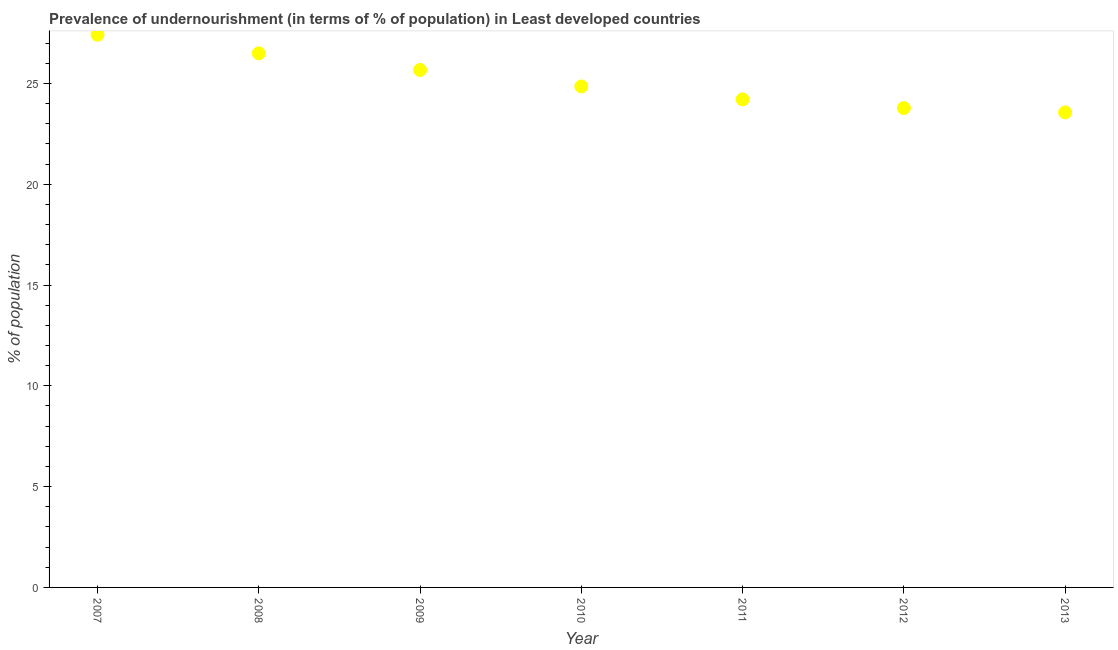What is the percentage of undernourished population in 2012?
Provide a short and direct response. 23.78. Across all years, what is the maximum percentage of undernourished population?
Offer a very short reply. 27.42. Across all years, what is the minimum percentage of undernourished population?
Ensure brevity in your answer.  23.57. What is the sum of the percentage of undernourished population?
Provide a succinct answer. 175.99. What is the difference between the percentage of undernourished population in 2007 and 2010?
Your answer should be very brief. 2.57. What is the average percentage of undernourished population per year?
Your answer should be very brief. 25.14. What is the median percentage of undernourished population?
Make the answer very short. 24.85. In how many years, is the percentage of undernourished population greater than 14 %?
Your answer should be very brief. 7. What is the ratio of the percentage of undernourished population in 2007 to that in 2011?
Offer a very short reply. 1.13. What is the difference between the highest and the second highest percentage of undernourished population?
Offer a very short reply. 0.92. What is the difference between the highest and the lowest percentage of undernourished population?
Offer a terse response. 3.85. In how many years, is the percentage of undernourished population greater than the average percentage of undernourished population taken over all years?
Offer a very short reply. 3. What is the difference between two consecutive major ticks on the Y-axis?
Your response must be concise. 5. What is the title of the graph?
Offer a terse response. Prevalence of undernourishment (in terms of % of population) in Least developed countries. What is the label or title of the Y-axis?
Provide a succinct answer. % of population. What is the % of population in 2007?
Give a very brief answer. 27.42. What is the % of population in 2008?
Keep it short and to the point. 26.49. What is the % of population in 2009?
Your response must be concise. 25.67. What is the % of population in 2010?
Offer a very short reply. 24.85. What is the % of population in 2011?
Provide a short and direct response. 24.21. What is the % of population in 2012?
Give a very brief answer. 23.78. What is the % of population in 2013?
Your response must be concise. 23.57. What is the difference between the % of population in 2007 and 2008?
Provide a short and direct response. 0.92. What is the difference between the % of population in 2007 and 2009?
Your answer should be very brief. 1.75. What is the difference between the % of population in 2007 and 2010?
Make the answer very short. 2.57. What is the difference between the % of population in 2007 and 2011?
Your answer should be compact. 3.21. What is the difference between the % of population in 2007 and 2012?
Keep it short and to the point. 3.64. What is the difference between the % of population in 2007 and 2013?
Offer a very short reply. 3.85. What is the difference between the % of population in 2008 and 2009?
Your response must be concise. 0.82. What is the difference between the % of population in 2008 and 2010?
Ensure brevity in your answer.  1.64. What is the difference between the % of population in 2008 and 2011?
Provide a succinct answer. 2.28. What is the difference between the % of population in 2008 and 2012?
Give a very brief answer. 2.71. What is the difference between the % of population in 2008 and 2013?
Provide a short and direct response. 2.93. What is the difference between the % of population in 2009 and 2010?
Offer a very short reply. 0.82. What is the difference between the % of population in 2009 and 2011?
Offer a terse response. 1.46. What is the difference between the % of population in 2009 and 2012?
Provide a short and direct response. 1.89. What is the difference between the % of population in 2009 and 2013?
Keep it short and to the point. 2.1. What is the difference between the % of population in 2010 and 2011?
Provide a short and direct response. 0.64. What is the difference between the % of population in 2010 and 2012?
Make the answer very short. 1.07. What is the difference between the % of population in 2010 and 2013?
Provide a short and direct response. 1.29. What is the difference between the % of population in 2011 and 2012?
Ensure brevity in your answer.  0.43. What is the difference between the % of population in 2011 and 2013?
Your answer should be compact. 0.65. What is the difference between the % of population in 2012 and 2013?
Provide a short and direct response. 0.21. What is the ratio of the % of population in 2007 to that in 2008?
Offer a terse response. 1.03. What is the ratio of the % of population in 2007 to that in 2009?
Your response must be concise. 1.07. What is the ratio of the % of population in 2007 to that in 2010?
Offer a very short reply. 1.1. What is the ratio of the % of population in 2007 to that in 2011?
Provide a succinct answer. 1.13. What is the ratio of the % of population in 2007 to that in 2012?
Make the answer very short. 1.15. What is the ratio of the % of population in 2007 to that in 2013?
Your answer should be compact. 1.16. What is the ratio of the % of population in 2008 to that in 2009?
Give a very brief answer. 1.03. What is the ratio of the % of population in 2008 to that in 2010?
Make the answer very short. 1.07. What is the ratio of the % of population in 2008 to that in 2011?
Keep it short and to the point. 1.09. What is the ratio of the % of population in 2008 to that in 2012?
Provide a short and direct response. 1.11. What is the ratio of the % of population in 2008 to that in 2013?
Make the answer very short. 1.12. What is the ratio of the % of population in 2009 to that in 2010?
Give a very brief answer. 1.03. What is the ratio of the % of population in 2009 to that in 2011?
Offer a terse response. 1.06. What is the ratio of the % of population in 2009 to that in 2012?
Your answer should be very brief. 1.08. What is the ratio of the % of population in 2009 to that in 2013?
Your answer should be very brief. 1.09. What is the ratio of the % of population in 2010 to that in 2012?
Make the answer very short. 1.04. What is the ratio of the % of population in 2010 to that in 2013?
Ensure brevity in your answer.  1.05. 